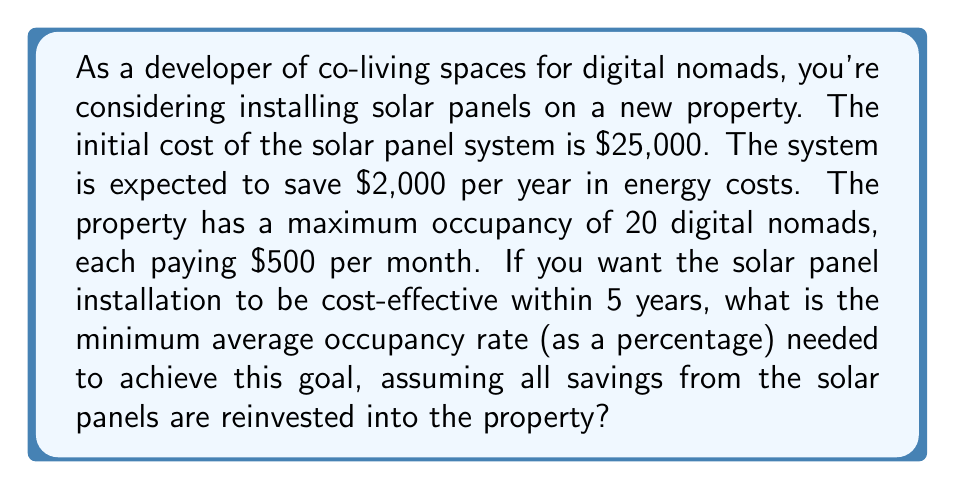Show me your answer to this math problem. Let's approach this problem step by step:

1) First, we need to calculate the total savings from the solar panels over 5 years:
   $$\text{Total Savings} = \$2,000 \times 5 \text{ years} = \$10,000$$

2) The cost-effectiveness threshold is reached when the savings equal the initial investment:
   $$\text{Cost-effectiveness threshold} = \$25,000$$

3) The shortfall that needs to be covered by occupancy revenue is:
   $$\text{Shortfall} = \$25,000 - \$10,000 = \$15,000$$

4) Now, let's calculate the maximum potential monthly revenue:
   $$\text{Max monthly revenue} = 20 \text{ nomads} \times \$500 = \$10,000$$

5) The total potential revenue over 5 years is:
   $$\text{Max 5-year revenue} = \$10,000 \times 12 \text{ months} \times 5 \text{ years} = \$600,000$$

6) Let $x$ be the occupancy rate as a decimal. The actual 5-year revenue needed to cover the shortfall is:
   $$\$600,000x = \$15,000$$

7) Solving for $x$:
   $$x = \frac{\$15,000}{\$600,000} = 0.025 = 2.5\%$$

8) Convert to a percentage:
   $$2.5\% \times 100 = 25\%$$

Therefore, the minimum average occupancy rate needed is 25%.
Answer: 25% 